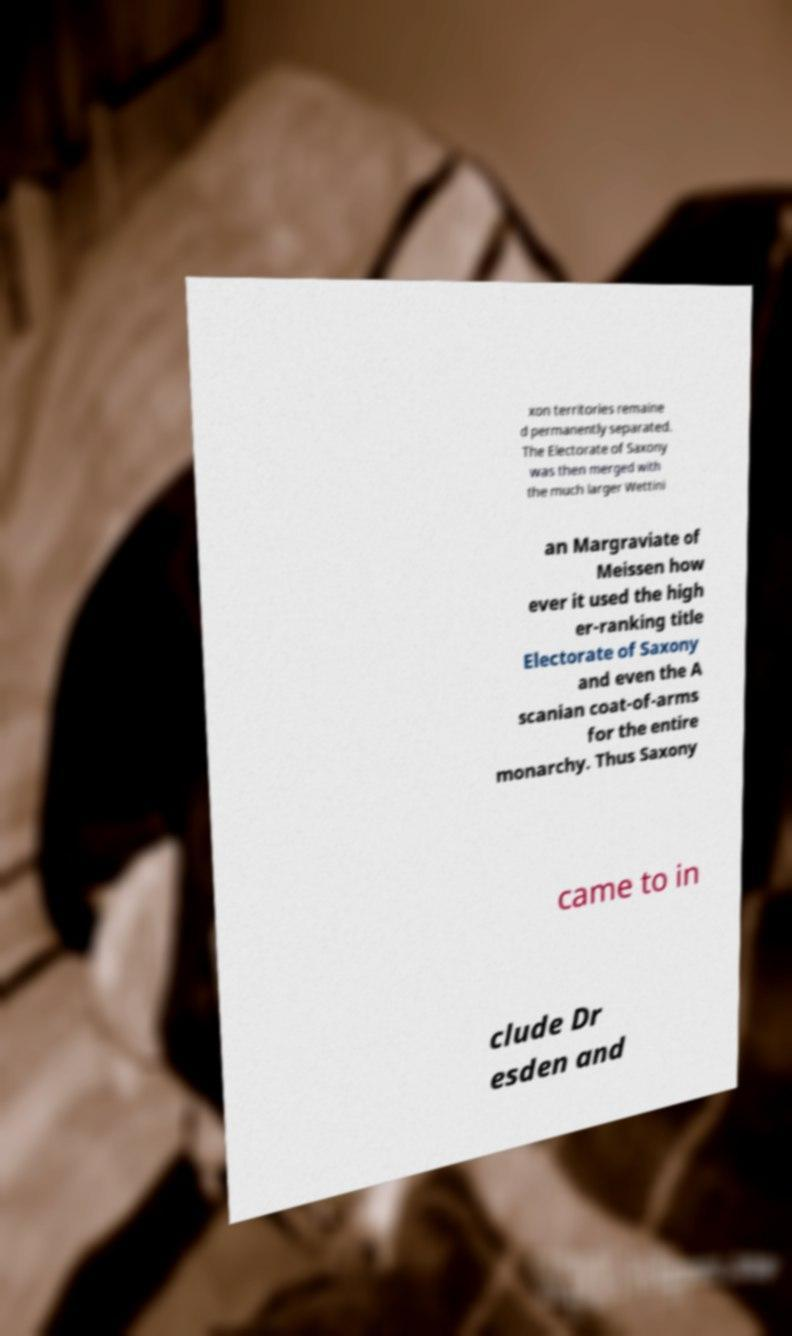Please read and relay the text visible in this image. What does it say? xon territories remaine d permanently separated. The Electorate of Saxony was then merged with the much larger Wettini an Margraviate of Meissen how ever it used the high er-ranking title Electorate of Saxony and even the A scanian coat-of-arms for the entire monarchy. Thus Saxony came to in clude Dr esden and 